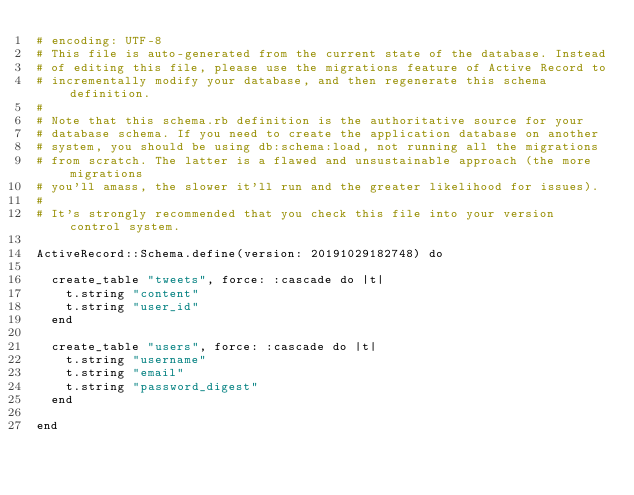<code> <loc_0><loc_0><loc_500><loc_500><_Ruby_># encoding: UTF-8
# This file is auto-generated from the current state of the database. Instead
# of editing this file, please use the migrations feature of Active Record to
# incrementally modify your database, and then regenerate this schema definition.
#
# Note that this schema.rb definition is the authoritative source for your
# database schema. If you need to create the application database on another
# system, you should be using db:schema:load, not running all the migrations
# from scratch. The latter is a flawed and unsustainable approach (the more migrations
# you'll amass, the slower it'll run and the greater likelihood for issues).
#
# It's strongly recommended that you check this file into your version control system.

ActiveRecord::Schema.define(version: 20191029182748) do

  create_table "tweets", force: :cascade do |t|
    t.string "content"
    t.string "user_id"
  end

  create_table "users", force: :cascade do |t|
    t.string "username"
    t.string "email"
    t.string "password_digest"
  end

end
</code> 